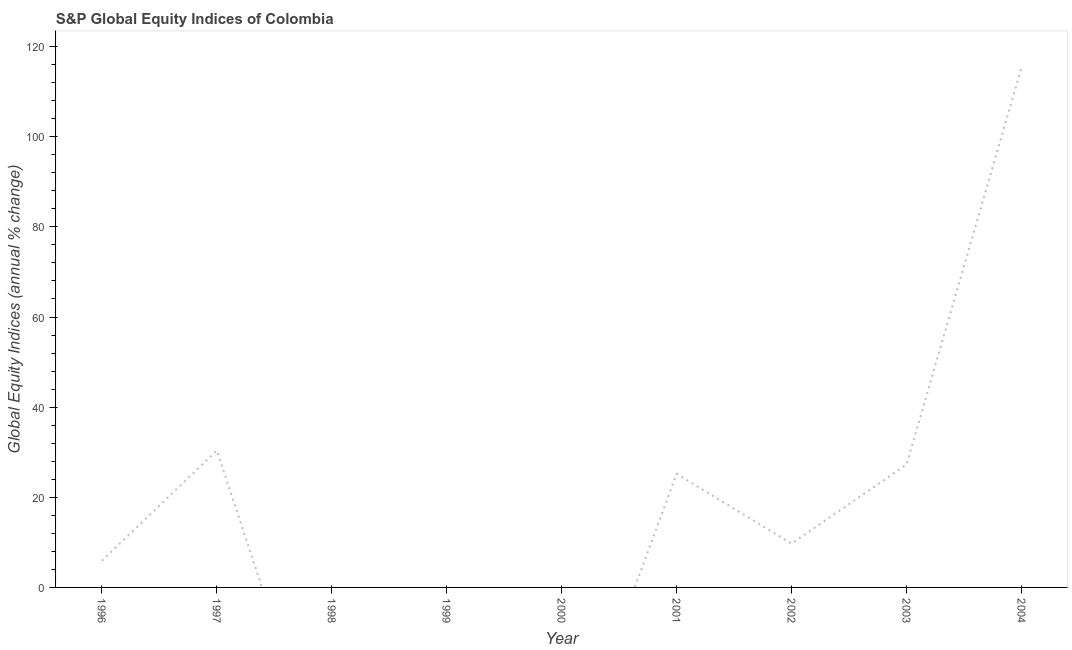What is the s&p global equity indices in 2003?
Your response must be concise. 27.27. Across all years, what is the maximum s&p global equity indices?
Offer a very short reply. 115.39. Across all years, what is the minimum s&p global equity indices?
Offer a terse response. 0. In which year was the s&p global equity indices maximum?
Offer a very short reply. 2004. What is the sum of the s&p global equity indices?
Ensure brevity in your answer.  213.85. What is the difference between the s&p global equity indices in 2003 and 2004?
Provide a short and direct response. -88.12. What is the average s&p global equity indices per year?
Provide a short and direct response. 23.76. What is the median s&p global equity indices?
Your answer should be very brief. 9.73. In how many years, is the s&p global equity indices greater than 56 %?
Make the answer very short. 1. What is the ratio of the s&p global equity indices in 2003 to that in 2004?
Ensure brevity in your answer.  0.24. Is the s&p global equity indices in 1996 less than that in 2003?
Your response must be concise. Yes. Is the difference between the s&p global equity indices in 1997 and 2002 greater than the difference between any two years?
Offer a very short reply. No. What is the difference between the highest and the second highest s&p global equity indices?
Your response must be concise. 85.02. What is the difference between the highest and the lowest s&p global equity indices?
Provide a succinct answer. 115.39. Does the s&p global equity indices monotonically increase over the years?
Your answer should be compact. No. How many lines are there?
Give a very brief answer. 1. What is the title of the graph?
Ensure brevity in your answer.  S&P Global Equity Indices of Colombia. What is the label or title of the X-axis?
Make the answer very short. Year. What is the label or title of the Y-axis?
Your answer should be compact. Global Equity Indices (annual % change). What is the Global Equity Indices (annual % change) in 1996?
Offer a very short reply. 5.9. What is the Global Equity Indices (annual % change) in 1997?
Your answer should be very brief. 30.37. What is the Global Equity Indices (annual % change) in 1998?
Provide a succinct answer. 0. What is the Global Equity Indices (annual % change) of 1999?
Your answer should be very brief. 0. What is the Global Equity Indices (annual % change) in 2001?
Offer a very short reply. 25.19. What is the Global Equity Indices (annual % change) in 2002?
Your answer should be compact. 9.73. What is the Global Equity Indices (annual % change) in 2003?
Provide a short and direct response. 27.27. What is the Global Equity Indices (annual % change) in 2004?
Give a very brief answer. 115.39. What is the difference between the Global Equity Indices (annual % change) in 1996 and 1997?
Your response must be concise. -24.47. What is the difference between the Global Equity Indices (annual % change) in 1996 and 2001?
Your response must be concise. -19.29. What is the difference between the Global Equity Indices (annual % change) in 1996 and 2002?
Make the answer very short. -3.83. What is the difference between the Global Equity Indices (annual % change) in 1996 and 2003?
Your response must be concise. -21.37. What is the difference between the Global Equity Indices (annual % change) in 1996 and 2004?
Provide a short and direct response. -109.49. What is the difference between the Global Equity Indices (annual % change) in 1997 and 2001?
Keep it short and to the point. 5.18. What is the difference between the Global Equity Indices (annual % change) in 1997 and 2002?
Ensure brevity in your answer.  20.64. What is the difference between the Global Equity Indices (annual % change) in 1997 and 2003?
Provide a succinct answer. 3.1. What is the difference between the Global Equity Indices (annual % change) in 1997 and 2004?
Make the answer very short. -85.02. What is the difference between the Global Equity Indices (annual % change) in 2001 and 2002?
Provide a short and direct response. 15.46. What is the difference between the Global Equity Indices (annual % change) in 2001 and 2003?
Offer a terse response. -2.08. What is the difference between the Global Equity Indices (annual % change) in 2001 and 2004?
Provide a succinct answer. -90.2. What is the difference between the Global Equity Indices (annual % change) in 2002 and 2003?
Offer a very short reply. -17.54. What is the difference between the Global Equity Indices (annual % change) in 2002 and 2004?
Keep it short and to the point. -105.66. What is the difference between the Global Equity Indices (annual % change) in 2003 and 2004?
Your answer should be compact. -88.12. What is the ratio of the Global Equity Indices (annual % change) in 1996 to that in 1997?
Your response must be concise. 0.19. What is the ratio of the Global Equity Indices (annual % change) in 1996 to that in 2001?
Offer a terse response. 0.23. What is the ratio of the Global Equity Indices (annual % change) in 1996 to that in 2002?
Offer a terse response. 0.61. What is the ratio of the Global Equity Indices (annual % change) in 1996 to that in 2003?
Make the answer very short. 0.22. What is the ratio of the Global Equity Indices (annual % change) in 1996 to that in 2004?
Your answer should be very brief. 0.05. What is the ratio of the Global Equity Indices (annual % change) in 1997 to that in 2001?
Give a very brief answer. 1.21. What is the ratio of the Global Equity Indices (annual % change) in 1997 to that in 2002?
Ensure brevity in your answer.  3.12. What is the ratio of the Global Equity Indices (annual % change) in 1997 to that in 2003?
Keep it short and to the point. 1.11. What is the ratio of the Global Equity Indices (annual % change) in 1997 to that in 2004?
Give a very brief answer. 0.26. What is the ratio of the Global Equity Indices (annual % change) in 2001 to that in 2002?
Make the answer very short. 2.59. What is the ratio of the Global Equity Indices (annual % change) in 2001 to that in 2003?
Keep it short and to the point. 0.92. What is the ratio of the Global Equity Indices (annual % change) in 2001 to that in 2004?
Keep it short and to the point. 0.22. What is the ratio of the Global Equity Indices (annual % change) in 2002 to that in 2003?
Provide a succinct answer. 0.36. What is the ratio of the Global Equity Indices (annual % change) in 2002 to that in 2004?
Give a very brief answer. 0.08. What is the ratio of the Global Equity Indices (annual % change) in 2003 to that in 2004?
Offer a very short reply. 0.24. 